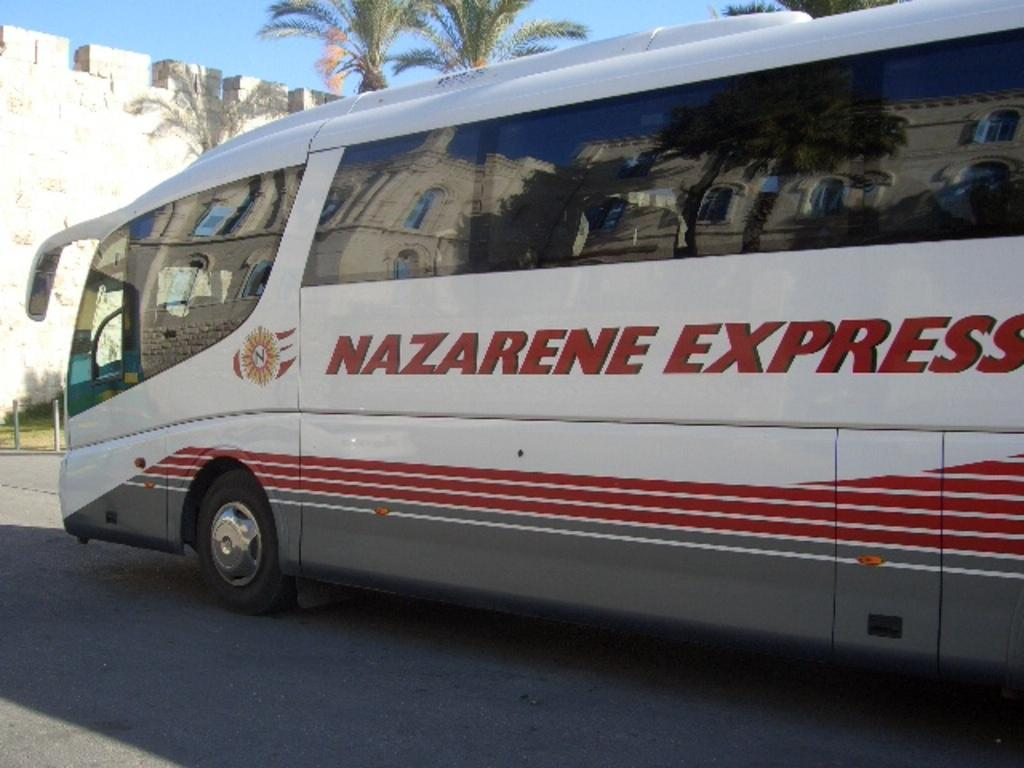<image>
Give a short and clear explanation of the subsequent image. A side view of Nazarene Express bus with red stripes. 